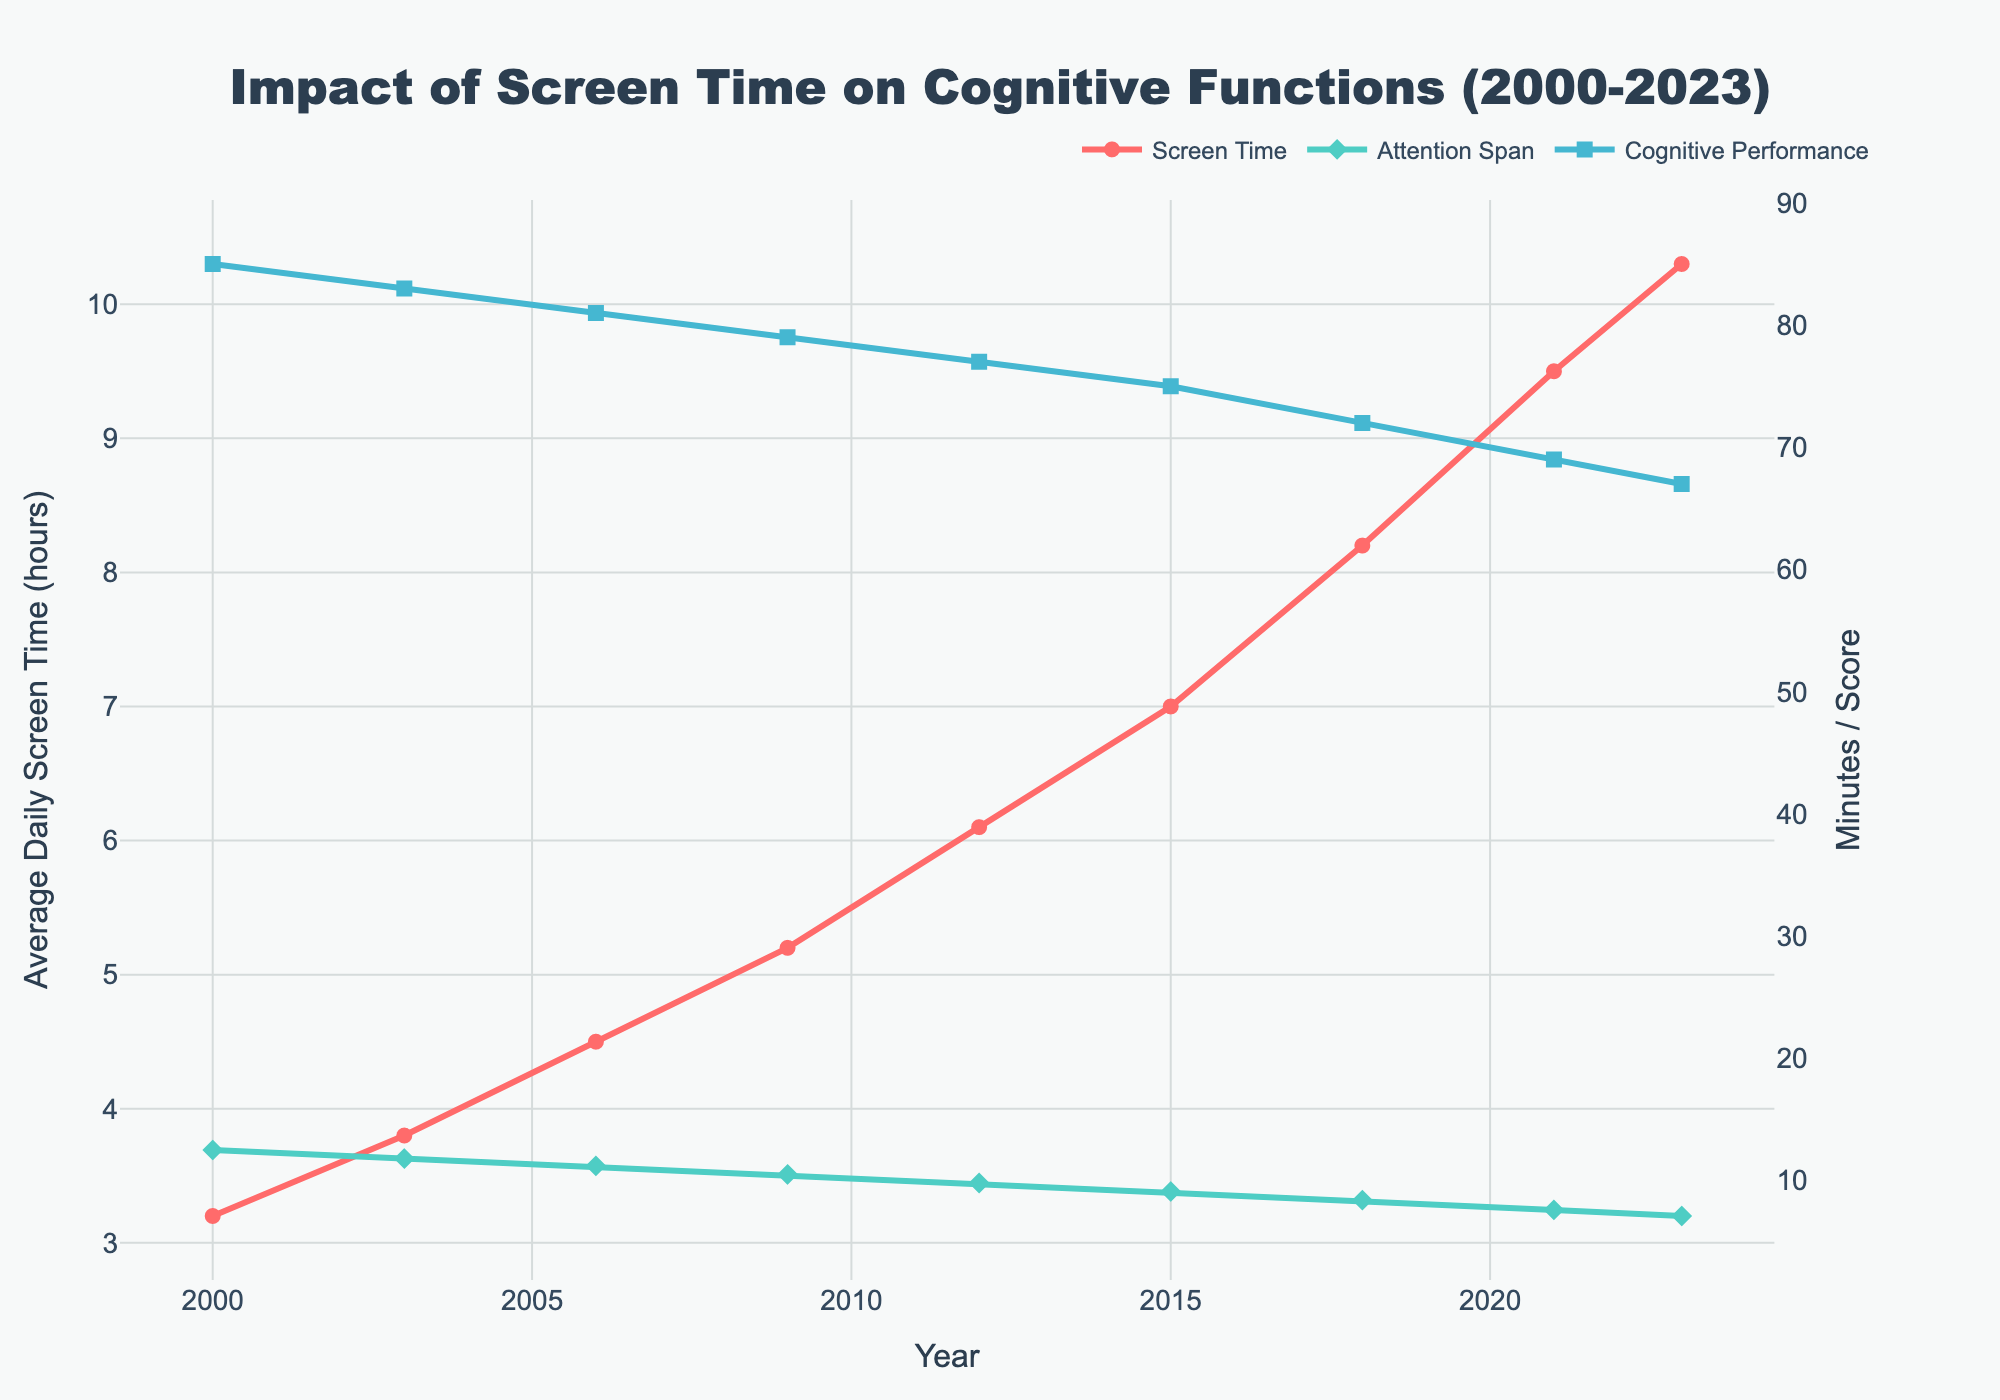What is the trend in average daily screen time from 2000 to 2023? The figure shows a continuous increase in average daily screen time from 3.2 hours in 2000 to 10.3 hours in 2023. This upward trend suggests more time is spent on screens over the years.
Answer: An upward trend How has the average attention span changed from 2000 to 2023? The figure illustrates a steady decline in average attention span, from 12.5 minutes in 2000 to 7.1 minutes in 2023. This indicates a decreasing trend in attention span over the years.
Answer: A downward trend What is the relationship between average daily screen time and average attention span over the time period? The visual comparison shows that as the average daily screen time increases, the average attention span decreases. This inverse relationship is evident when observing the upward trend in screen time and the downward trend in attention span.
Answer: Inversely related By how many minutes did the average attention span decrease between 2000 and 2023? The average attention span decreased from 12.5 minutes in 2000 to 7.1 minutes in 2023. Subtracting these values gives: 12.5 - 7.1 = 5.4 minutes.
Answer: 5.4 minutes How does the cognitive task performance score in 2000 compare to that in 2023? The figure shows that the cognitive task performance score decreased from 85 in 2000 to 67 in 2023. This indicates a reduction in cognitive task performance over the years.
Answer: Reduced What is the maximum average daily screen time, and in which year was it recorded? The line for average daily screen time peaks at 10.3 hours in 2023, indicating the highest value of screen time was recorded in 2023.
Answer: 10.3 hours, 2023 Which year saw the highest cognitive task performance score, and what was the value? The highest cognitive task performance score is marked in 2000 with a value of 85, as indicated by the figure.
Answer: 2000, 85 By how many hours did the average daily screen time increase from 2015 to 2021? The screen time in 2015 was 7.0 hours and in 2021 it was 9.5 hours. Subtracting these values gives: 9.5 - 7 = 2.5 hours.
Answer: 2.5 hours What are the different visual attributes used to represent average daily screen time, average attention span, and cognitive task performance score in the chart? The average daily screen time is depicted with red lines and circle markers, average attention span with green lines and diamond markers, and cognitive task performance score with blue lines and square markers.
Answer: Red lines and circles, green lines and diamonds, blue lines and squares Which metric shows the steepest decline, and what could be the possible interpretation of this trend? The attention span shows the steepest decline from 12.5 minutes in 2000 to 7.1 minutes in 2023. This significant decrease might suggest that increased screen time is strongly impacting individuals' ability to maintain attention, leading to lower cognitive task performance.
Answer: Attention span 